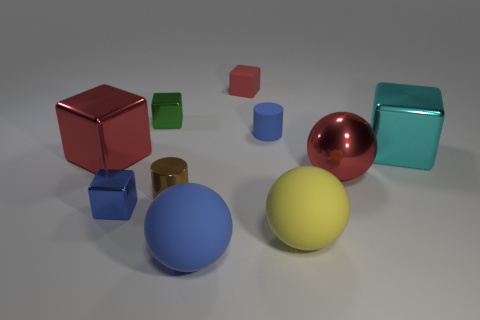Subtract all matte balls. How many balls are left? 1 Subtract all red blocks. How many blocks are left? 3 Subtract all cyan cubes. Subtract all cyan balls. How many cubes are left? 4 Subtract all cylinders. How many objects are left? 8 Add 8 big yellow things. How many big yellow things are left? 9 Add 6 red matte cylinders. How many red matte cylinders exist? 6 Subtract 0 purple spheres. How many objects are left? 10 Subtract all large metal balls. Subtract all tiny matte objects. How many objects are left? 7 